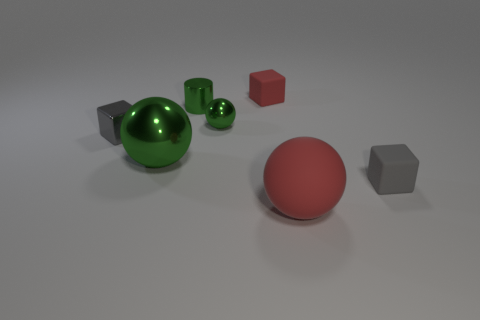Subtract all blue blocks. Subtract all red spheres. How many blocks are left? 3 Add 2 tiny gray objects. How many objects exist? 9 Subtract all cubes. How many objects are left? 4 Subtract 0 cyan cylinders. How many objects are left? 7 Subtract all big purple matte spheres. Subtract all red rubber blocks. How many objects are left? 6 Add 3 balls. How many balls are left? 6 Add 4 small matte things. How many small matte things exist? 6 